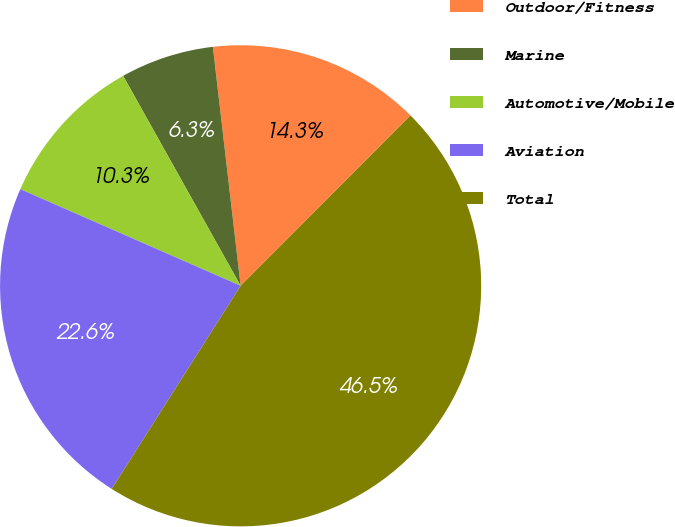<chart> <loc_0><loc_0><loc_500><loc_500><pie_chart><fcel>Outdoor/Fitness<fcel>Marine<fcel>Automotive/Mobile<fcel>Aviation<fcel>Total<nl><fcel>14.32%<fcel>6.28%<fcel>10.3%<fcel>22.58%<fcel>46.52%<nl></chart> 